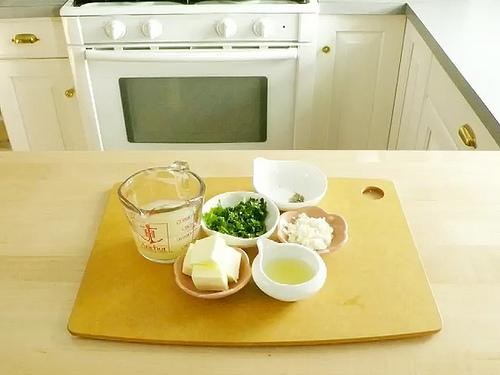Which one of these processes produced the spread here? blender 